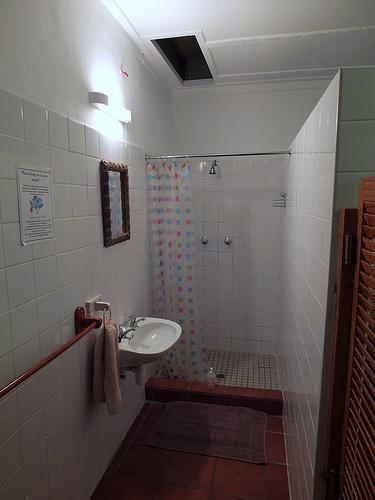How many shower curtains are in the photo?
Give a very brief answer. 1. How many mirrors are in the room?
Give a very brief answer. 1. How many sinks are in the picture?
Give a very brief answer. 1. How many towels are in the scene?
Give a very brief answer. 1. 